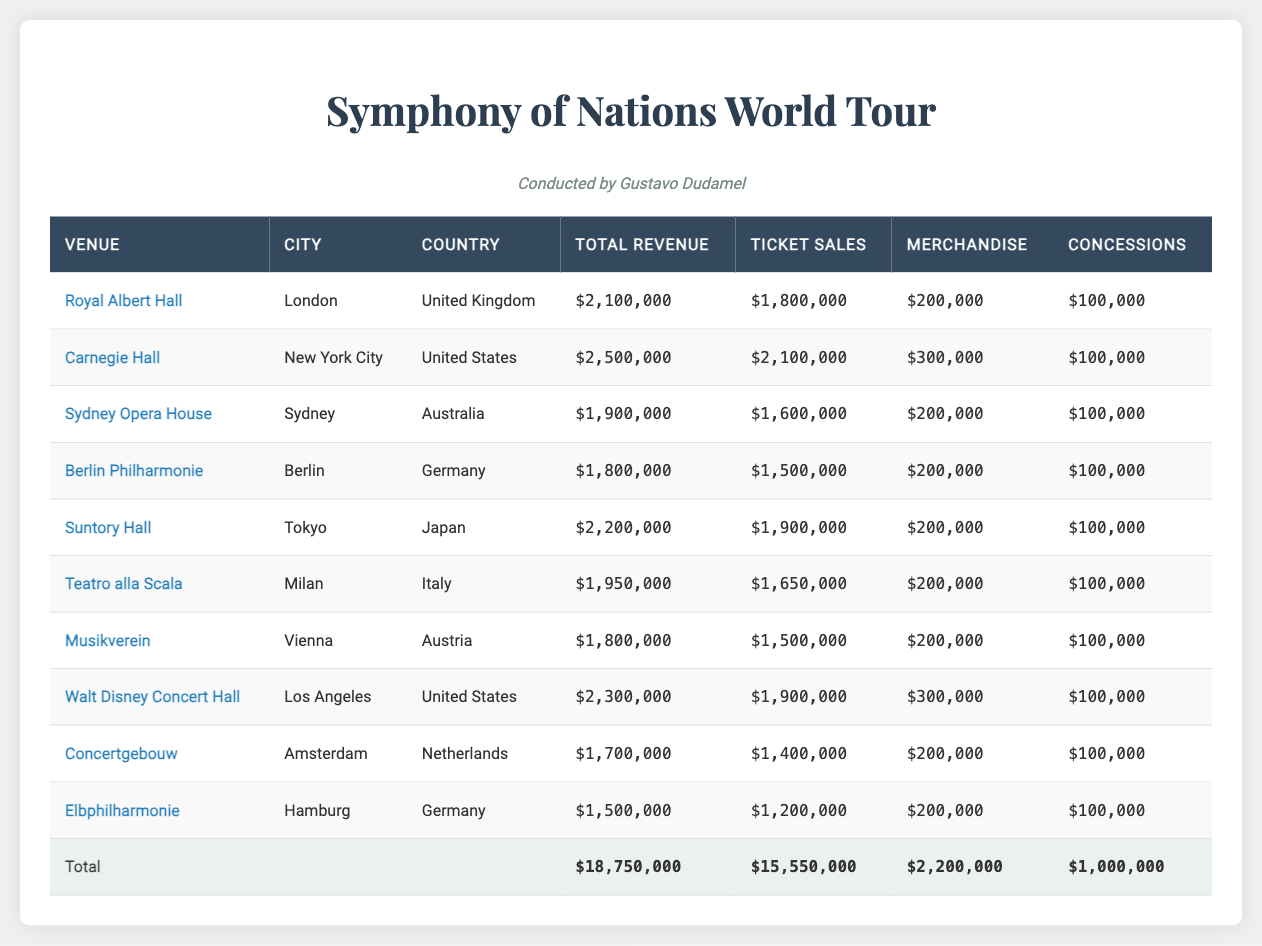What is the total revenue from the Concertgebouw? The row for the Concertgebouw shows a total revenue of $1,700,000.
Answer: $1,700,000 Which city has the highest revenue from ticket sales? By examining the ticket sales column, Carnegie Hall has the highest ticket sales of $2,100,000.
Answer: New York City What is the total revenue from all venues combined? The total revenue row at the bottom of the table indicates that the total revenue is $18,750,000.
Answer: $18,750,000 Is the merchandise revenue for Suntory Hall greater than that for the Sydney Opera House? Suntory Hall has merchandise revenue of $200,000, while Sydney Opera House also has $200,000, thus they are equal.
Answer: No What is the average total revenue across all venues? To calculate the average, add all the venue revenues: $2,100,000 + $2,500,000 + $1,900,000 + $1,800,000 + $2,200,000 + $1,950,000 + $1,800,000 + $2,300,000 + $1,700,000 + $1,500,000 = $18,750,000. Then divide by the number of venues (10): $18,750,000 / 10 = $1,875,000.
Answer: $1,875,000 How much revenue did the Japanese venues generate in total? There is one venue from Japan, Suntory Hall, which generated $2,200,000. Therefore, the total revenue from Japanese venues is directly this figure.
Answer: $2,200,000 Which venue had the least revenue overall? Looking through the venues, Elbphilharmonie has the least revenue at $1,500,000.
Answer: Elbphilharmonie Is the total revenue from merchandise greater than $2,000,000? The total merchandise revenue can be summed: $200,000 (Royal Albert Hall) + $300,000 (Carnegie Hall) + $200,000 (Sydney Opera House) + $200,000 (Berlin Philharmonie) + $200,000 (Suntory Hall) + $200,000 (Teatro alla Scala) + $200,000 (Musikverein) + $300,000 (Walt Disney Concert Hall) + $200,000 (Concertgebouw) + $200,000 (Elbphilharmonie) = $2,200,000. Since $2,200,000 is greater than $2,000,000, the answer is yes.
Answer: Yes What percentage of total revenue came from ticket sales? Total ticket sales are $15,550,000, and total revenue is $18,750,000. The percentage of ticket sales is calculated as ($15,550,000 / $18,750,000) * 100 = 82.67%.
Answer: 82.67% 